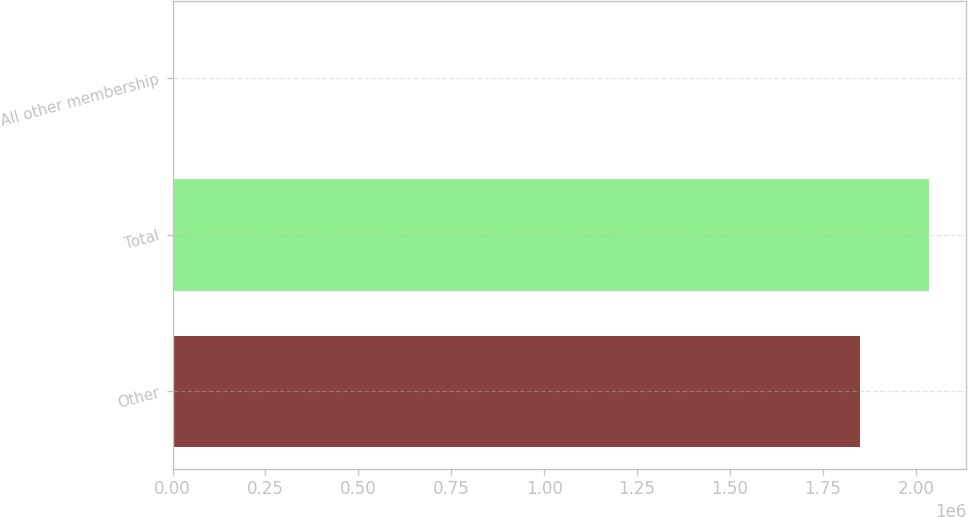Convert chart. <chart><loc_0><loc_0><loc_500><loc_500><bar_chart><fcel>Other<fcel>Total<fcel>All other membership<nl><fcel>1.8497e+06<fcel>2.03466e+06<fcel>100<nl></chart> 